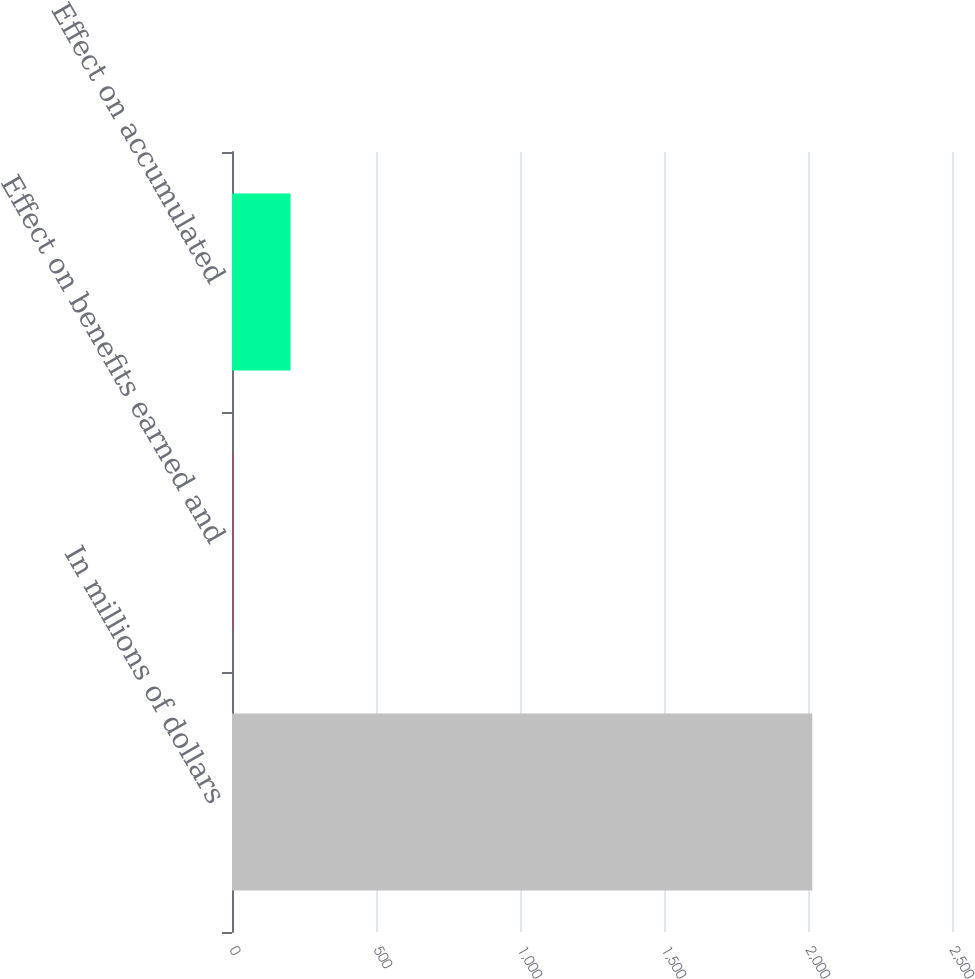Convert chart. <chart><loc_0><loc_0><loc_500><loc_500><bar_chart><fcel>In millions of dollars<fcel>Effect on benefits earned and<fcel>Effect on accumulated<nl><fcel>2015<fcel>2<fcel>203.3<nl></chart> 